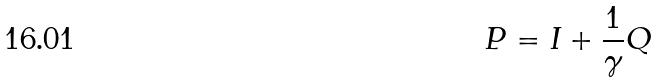Convert formula to latex. <formula><loc_0><loc_0><loc_500><loc_500>P = I + \frac { 1 } { \gamma } Q</formula> 